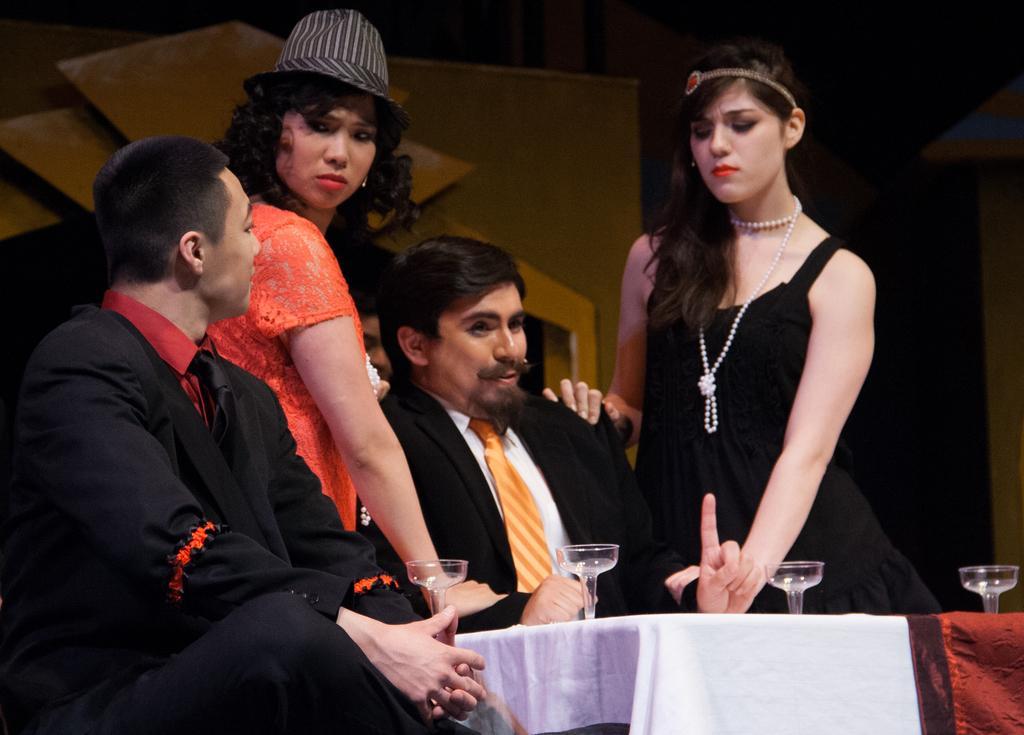In one or two sentences, can you explain what this image depicts? In this picture we can see two men sitting. We can see a few glasses on the tables. There is a white and a maroon cloth is visible on the tables. We can see two women standing. There are some objects visible in the background. 